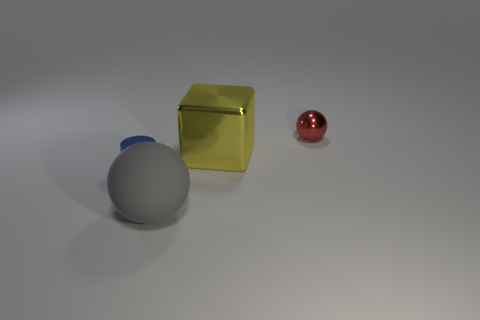What is the color of the thing that is to the left of the sphere in front of the small sphere? To the left of the larger sphere, which is positioned in front of the small red sphere, there is a yellow cubic object. 